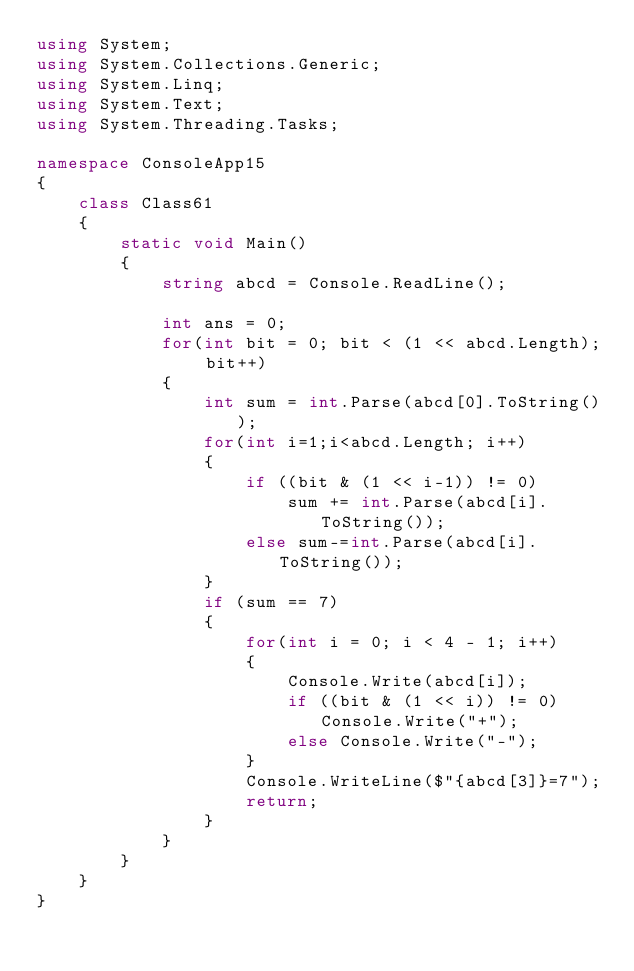<code> <loc_0><loc_0><loc_500><loc_500><_C#_>using System;
using System.Collections.Generic;
using System.Linq;
using System.Text;
using System.Threading.Tasks;

namespace ConsoleApp15
{
    class Class61
    {
        static void Main()
        {
            string abcd = Console.ReadLine();

            int ans = 0;
            for(int bit = 0; bit < (1 << abcd.Length); bit++)
            {
                int sum = int.Parse(abcd[0].ToString());
                for(int i=1;i<abcd.Length; i++)
                {
                    if ((bit & (1 << i-1)) != 0)
                        sum += int.Parse(abcd[i].ToString());
                    else sum-=int.Parse(abcd[i].ToString());
                }
                if (sum == 7)
                {
                    for(int i = 0; i < 4 - 1; i++)
                    {
                        Console.Write(abcd[i]);
                        if ((bit & (1 << i)) != 0) Console.Write("+");
                        else Console.Write("-");
                    }
                    Console.WriteLine($"{abcd[3]}=7");
                    return;
                }
            }
        }
    }
}
</code> 